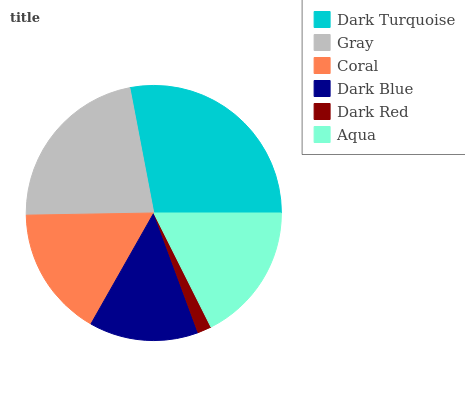Is Dark Red the minimum?
Answer yes or no. Yes. Is Dark Turquoise the maximum?
Answer yes or no. Yes. Is Gray the minimum?
Answer yes or no. No. Is Gray the maximum?
Answer yes or no. No. Is Dark Turquoise greater than Gray?
Answer yes or no. Yes. Is Gray less than Dark Turquoise?
Answer yes or no. Yes. Is Gray greater than Dark Turquoise?
Answer yes or no. No. Is Dark Turquoise less than Gray?
Answer yes or no. No. Is Aqua the high median?
Answer yes or no. Yes. Is Coral the low median?
Answer yes or no. Yes. Is Gray the high median?
Answer yes or no. No. Is Gray the low median?
Answer yes or no. No. 